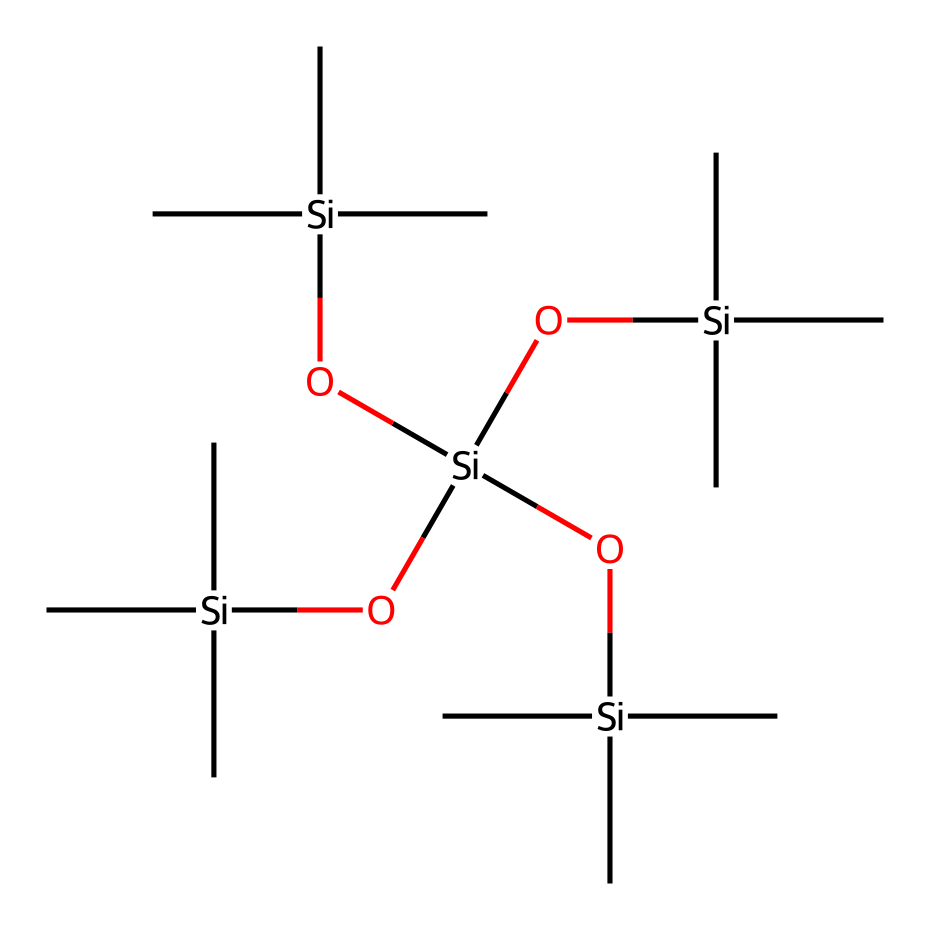What is the total number of silicon atoms in this silane structure? The provided SMILES representation indicates there are five silicon atoms, as indicated by the five occurrences of "[Si]" in the chemical structure.
Answer: five How many hydroxyl groups are attached to the silicon atoms? There are four hydroxyl groups represented by the "O" connected to each silicon, which makes a total of four hydroxyl groups in this structure.
Answer: four What type of silane is represented in this chemical structure? Given the presence of multiple alkyl groups and hydroxyl functionalities, this structure is classified as a tetrafunctional silane.
Answer: tetrafunctional What is the molecular geometry around each silicon atom? Each silicon atom in this silane configuration exhibits tetrahedral geometry due to the presence of four substituents: three alkyl groups and one hydroxyl group.
Answer: tetrahedral How many branches are present in the alkyl groups of this silane? The alkyl groups depicted here are branched with three carbons each, which indicates a total of four branches stemming from the central silicon atoms.
Answer: four What is the primary use of this type of silane in relation to historical artifacts? This type of silane is primarily used in protective coatings for historical legal artifacts, providing a barrier that can prevent moisture and pollutants from damaging the materials.
Answer: protective coatings 